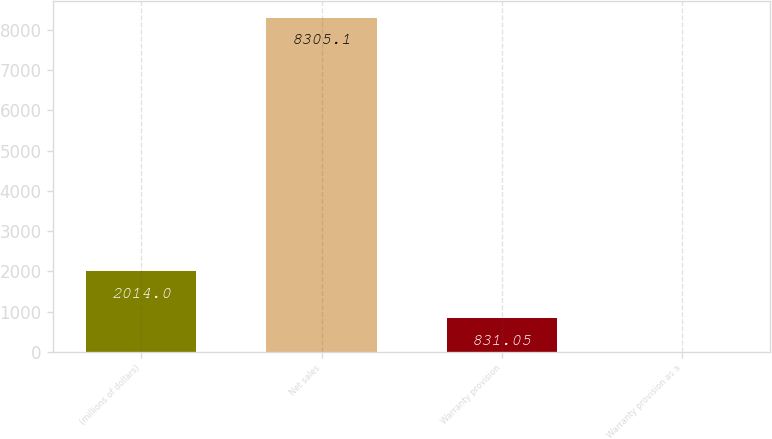Convert chart. <chart><loc_0><loc_0><loc_500><loc_500><bar_chart><fcel>(millions of dollars)<fcel>Net sales<fcel>Warranty provision<fcel>Warranty provision as a<nl><fcel>2014<fcel>8305.1<fcel>831.05<fcel>0.6<nl></chart> 